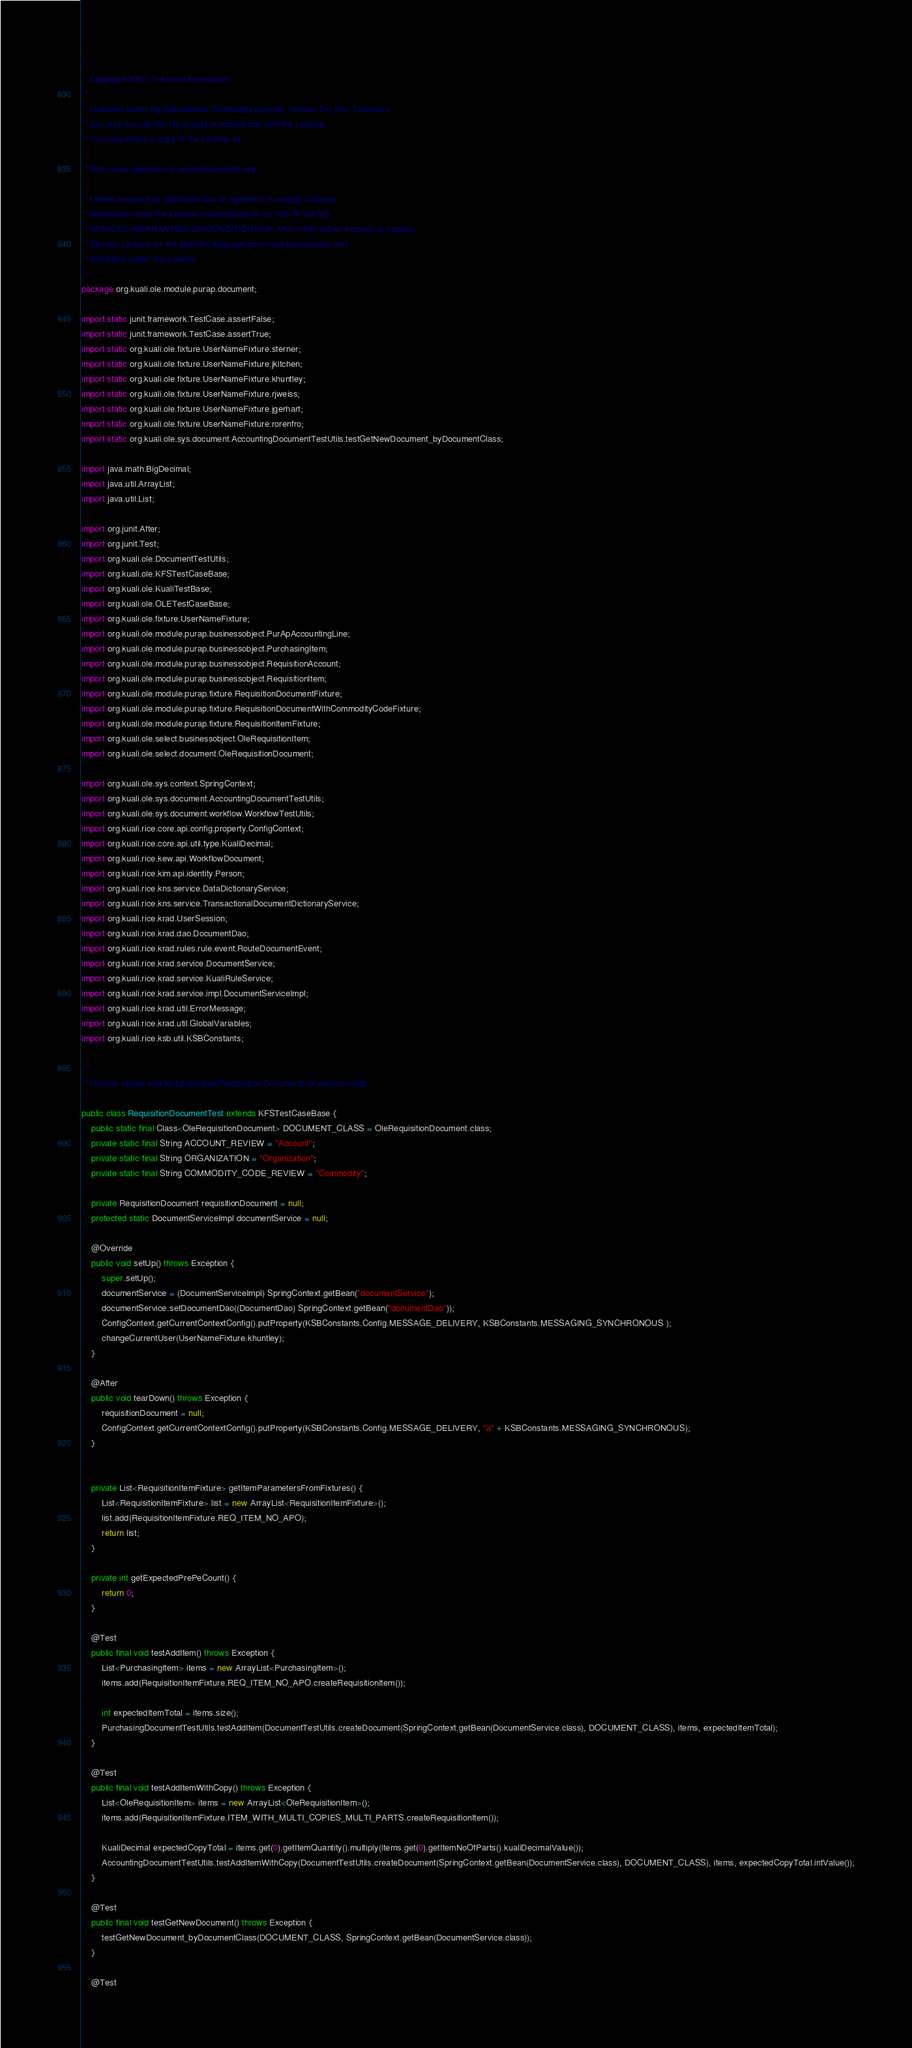<code> <loc_0><loc_0><loc_500><loc_500><_Java_>/*
 * Copyright 2007 The Kuali Foundation
 *
 * Licensed under the Educational Community License, Version 2.0 (the "License");
 * you may not use this file except in compliance with the License.
 * You may obtain a copy of the License at
 *
 * http://www.opensource.org/licenses/ecl2.php
 *
 * Unless required by applicable law or agreed to in writing, software
 * distributed under the License is distributed on an "AS IS" BASIS,
 * WITHOUT WARRANTIES OR CONDITIONS OF ANY KIND, either express or implied.
 * See the License for the specific language governing permissions and
 * limitations under the License.
 */
package org.kuali.ole.module.purap.document;

import static junit.framework.TestCase.assertFalse;
import static junit.framework.TestCase.assertTrue;
import static org.kuali.ole.fixture.UserNameFixture.sterner;
import static org.kuali.ole.fixture.UserNameFixture.jkitchen;
import static org.kuali.ole.fixture.UserNameFixture.khuntley;
import static org.kuali.ole.fixture.UserNameFixture.rjweiss;
import static org.kuali.ole.fixture.UserNameFixture.jgerhart;
import static org.kuali.ole.fixture.UserNameFixture.rorenfro;
import static org.kuali.ole.sys.document.AccountingDocumentTestUtils.testGetNewDocument_byDocumentClass;

import java.math.BigDecimal;
import java.util.ArrayList;
import java.util.List;

import org.junit.After;
import org.junit.Test;
import org.kuali.ole.DocumentTestUtils;
import org.kuali.ole.KFSTestCaseBase;
import org.kuali.ole.KualiTestBase;
import org.kuali.ole.OLETestCaseBase;
import org.kuali.ole.fixture.UserNameFixture;
import org.kuali.ole.module.purap.businessobject.PurApAccountingLine;
import org.kuali.ole.module.purap.businessobject.PurchasingItem;
import org.kuali.ole.module.purap.businessobject.RequisitionAccount;
import org.kuali.ole.module.purap.businessobject.RequisitionItem;
import org.kuali.ole.module.purap.fixture.RequisitionDocumentFixture;
import org.kuali.ole.module.purap.fixture.RequisitionDocumentWithCommodityCodeFixture;
import org.kuali.ole.module.purap.fixture.RequisitionItemFixture;
import org.kuali.ole.select.businessobject.OleRequisitionItem;
import org.kuali.ole.select.document.OleRequisitionDocument;

import org.kuali.ole.sys.context.SpringContext;
import org.kuali.ole.sys.document.AccountingDocumentTestUtils;
import org.kuali.ole.sys.document.workflow.WorkflowTestUtils;
import org.kuali.rice.core.api.config.property.ConfigContext;
import org.kuali.rice.core.api.util.type.KualiDecimal;
import org.kuali.rice.kew.api.WorkflowDocument;
import org.kuali.rice.kim.api.identity.Person;
import org.kuali.rice.kns.service.DataDictionaryService;
import org.kuali.rice.kns.service.TransactionalDocumentDictionaryService;
import org.kuali.rice.krad.UserSession;
import org.kuali.rice.krad.dao.DocumentDao;
import org.kuali.rice.krad.rules.rule.event.RouteDocumentEvent;
import org.kuali.rice.krad.service.DocumentService;
import org.kuali.rice.krad.service.KualiRuleService;
import org.kuali.rice.krad.service.impl.DocumentServiceImpl;
import org.kuali.rice.krad.util.ErrorMessage;
import org.kuali.rice.krad.util.GlobalVariables;
import org.kuali.rice.ksb.util.KSBConstants;

/**
 * Used to create and test populated Requisition Documents of various kinds.
 */
public class RequisitionDocumentTest extends KFSTestCaseBase {
    public static final Class<OleRequisitionDocument> DOCUMENT_CLASS = OleRequisitionDocument.class;
    private static final String ACCOUNT_REVIEW = "Account";
    private static final String ORGANIZATION = "Organization";
    private static final String COMMODITY_CODE_REVIEW = "Commodity";

    private RequisitionDocument requisitionDocument = null;
    protected static DocumentServiceImpl documentService = null;

    @Override
    public void setUp() throws Exception {
        super.setUp();
        documentService = (DocumentServiceImpl) SpringContext.getBean("documentService");
        documentService.setDocumentDao((DocumentDao) SpringContext.getBean("documentDao"));
        ConfigContext.getCurrentContextConfig().putProperty(KSBConstants.Config.MESSAGE_DELIVERY, KSBConstants.MESSAGING_SYNCHRONOUS );
        changeCurrentUser(UserNameFixture.khuntley);
    }

    @After
    public void tearDown() throws Exception {
        requisitionDocument = null;
        ConfigContext.getCurrentContextConfig().putProperty(KSBConstants.Config.MESSAGE_DELIVERY, "a" + KSBConstants.MESSAGING_SYNCHRONOUS);
    }


    private List<RequisitionItemFixture> getItemParametersFromFixtures() {
        List<RequisitionItemFixture> list = new ArrayList<RequisitionItemFixture>();
        list.add(RequisitionItemFixture.REQ_ITEM_NO_APO);
        return list;
    }

    private int getExpectedPrePeCount() {
        return 0;
    }

    @Test
    public final void testAddItem() throws Exception {
        List<PurchasingItem> items = new ArrayList<PurchasingItem>();
        items.add(RequisitionItemFixture.REQ_ITEM_NO_APO.createRequisitionItem());

        int expectedItemTotal = items.size();
        PurchasingDocumentTestUtils.testAddItem(DocumentTestUtils.createDocument(SpringContext.getBean(DocumentService.class), DOCUMENT_CLASS), items, expectedItemTotal);
    }

    @Test
    public final void testAddItemWithCopy() throws Exception {
        List<OleRequisitionItem> items = new ArrayList<OleRequisitionItem>();
        items.add(RequisitionItemFixture.ITEM_WITH_MULTI_COPIES_MULTI_PARTS.createRequisitionItem());

        KualiDecimal expectedCopyTotal = items.get(0).getItemQuantity().multiply(items.get(0).getItemNoOfParts().kualiDecimalValue());
        AccountingDocumentTestUtils.testAddItemWithCopy(DocumentTestUtils.createDocument(SpringContext.getBean(DocumentService.class), DOCUMENT_CLASS), items, expectedCopyTotal.intValue());
    }

    @Test
    public final void testGetNewDocument() throws Exception {
        testGetNewDocument_byDocumentClass(DOCUMENT_CLASS, SpringContext.getBean(DocumentService.class));
    }

    @Test</code> 